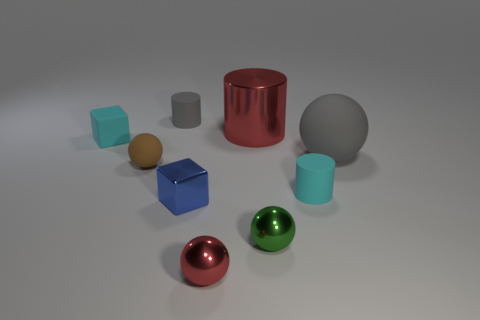What number of other things are made of the same material as the small brown thing?
Provide a succinct answer. 4. There is a ball behind the brown thing; are there any small brown balls that are in front of it?
Your response must be concise. Yes. Are there any other things that are the same shape as the large gray object?
Keep it short and to the point. Yes. The large thing that is the same shape as the tiny brown rubber thing is what color?
Give a very brief answer. Gray. The red ball is what size?
Ensure brevity in your answer.  Small. Are there fewer rubber things to the left of the brown matte object than red objects?
Make the answer very short. Yes. Is the material of the tiny blue object the same as the small cyan object on the right side of the small red ball?
Provide a short and direct response. No. Is there a cyan block behind the matte cylinder that is behind the small matte object on the right side of the gray matte cylinder?
Ensure brevity in your answer.  No. Is there any other thing that has the same size as the cyan rubber cylinder?
Your answer should be compact. Yes. What color is the cube that is the same material as the big cylinder?
Ensure brevity in your answer.  Blue. 